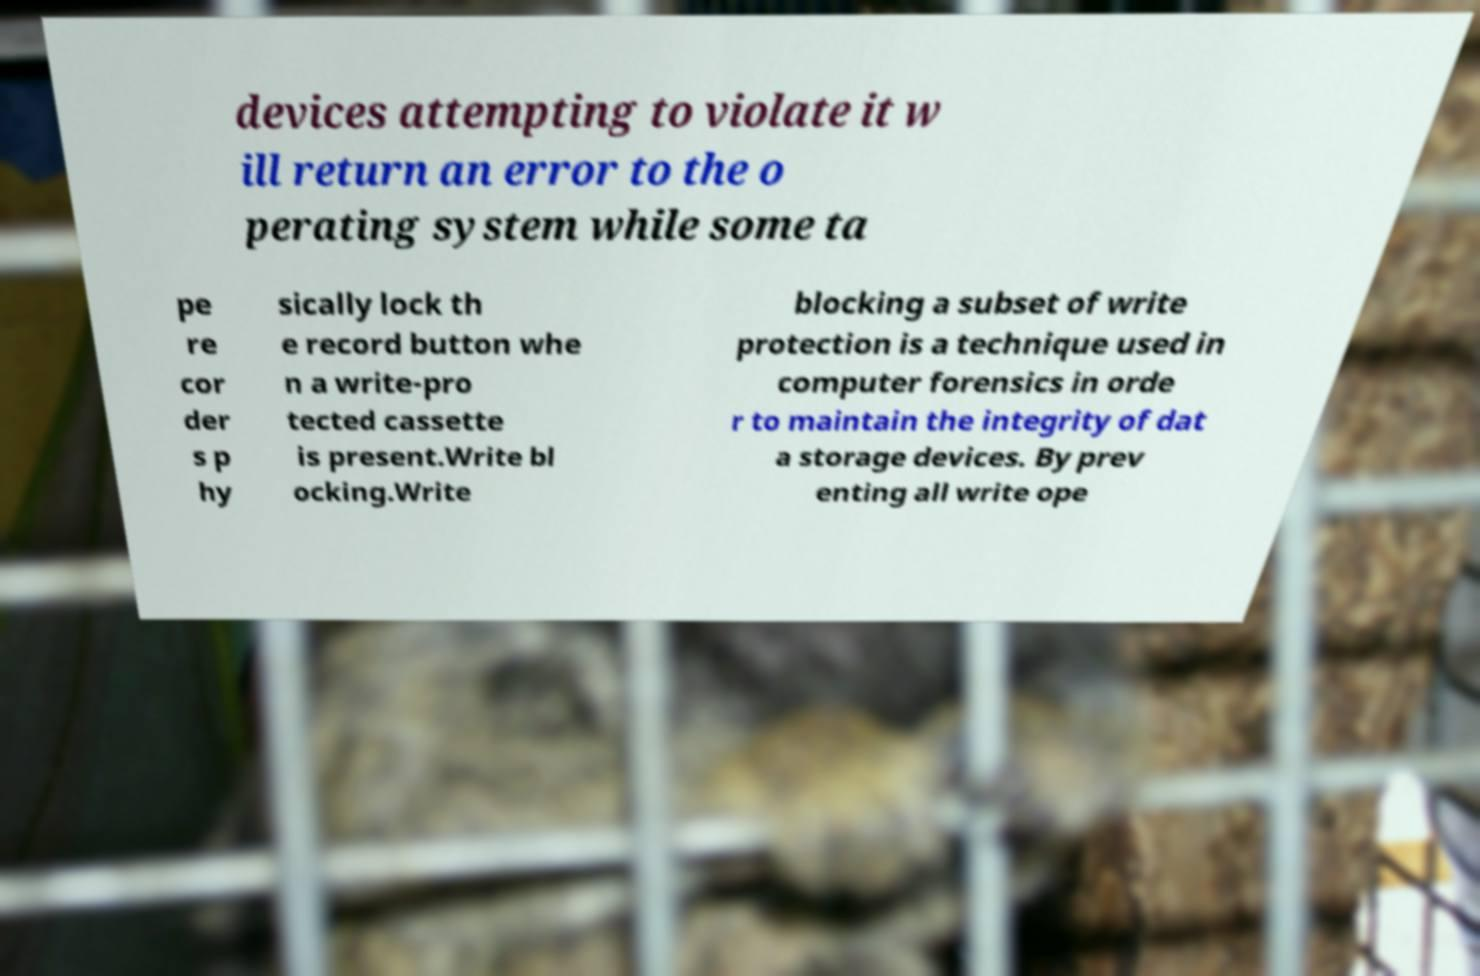Please read and relay the text visible in this image. What does it say? devices attempting to violate it w ill return an error to the o perating system while some ta pe re cor der s p hy sically lock th e record button whe n a write-pro tected cassette is present.Write bl ocking.Write blocking a subset of write protection is a technique used in computer forensics in orde r to maintain the integrity of dat a storage devices. By prev enting all write ope 